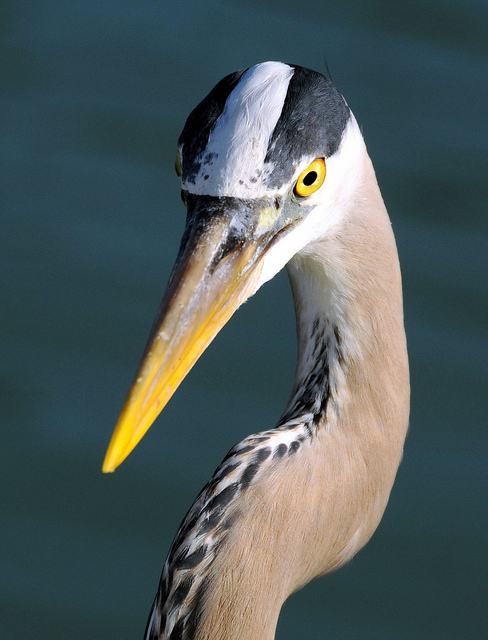Can you tell me where Grey Herons are commonly found? Grey Herons are widely distributed across temperate Europe and Asia. They are commonly found near bodies of water such as lakes, rivers, ponds, and marshes where they can hunt for fish and aquatic creatures. 